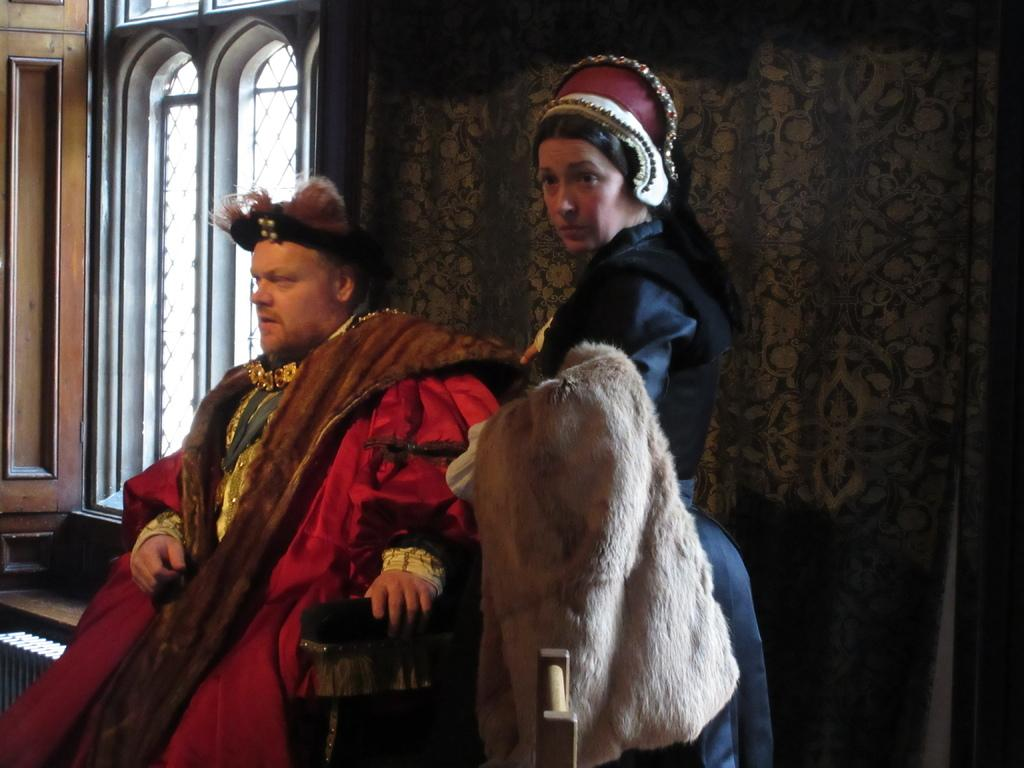Who are the people in the image? There is a lady and a man in the image. What is the lady carrying in the image? The lady is carrying a cloth in the image. What can be seen in the background of the image? There is a window and a wall in the image. How does the man rub the wall in the image? There is no indication in the image that the man is rubbing the wall. 